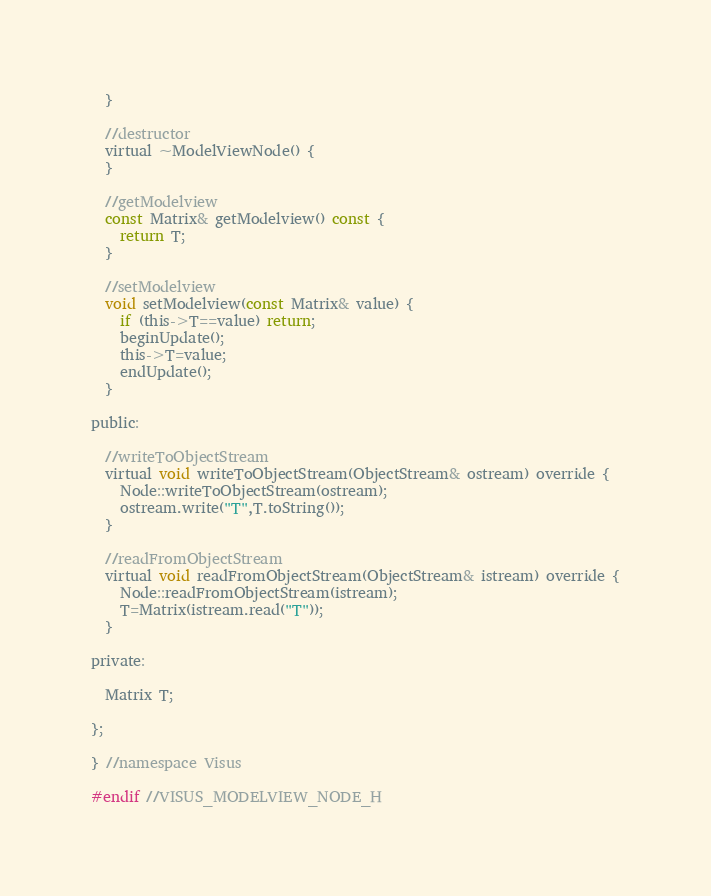Convert code to text. <code><loc_0><loc_0><loc_500><loc_500><_C_>  }

  //destructor
  virtual ~ModelViewNode() {
  }

  //getModelview
  const Matrix& getModelview() const {
    return T;
  }

  //setModelview
  void setModelview(const Matrix& value) {
    if (this->T==value) return;
    beginUpdate();
    this->T=value;
    endUpdate();
  }

public:

  //writeToObjectStream
  virtual void writeToObjectStream(ObjectStream& ostream) override {
    Node::writeToObjectStream(ostream);
    ostream.write("T",T.toString());
  }

  //readFromObjectStream
  virtual void readFromObjectStream(ObjectStream& istream) override {
    Node::readFromObjectStream(istream);
    T=Matrix(istream.read("T"));
  }

private:

  Matrix T;

};

} //namespace Visus

#endif //VISUS_MODELVIEW_NODE_H

</code> 